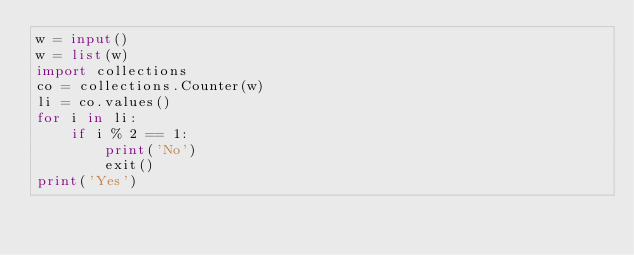<code> <loc_0><loc_0><loc_500><loc_500><_Python_>w = input()
w = list(w)
import collections
co = collections.Counter(w)
li = co.values()
for i in li:
    if i % 2 == 1:
        print('No')
        exit()
print('Yes')</code> 